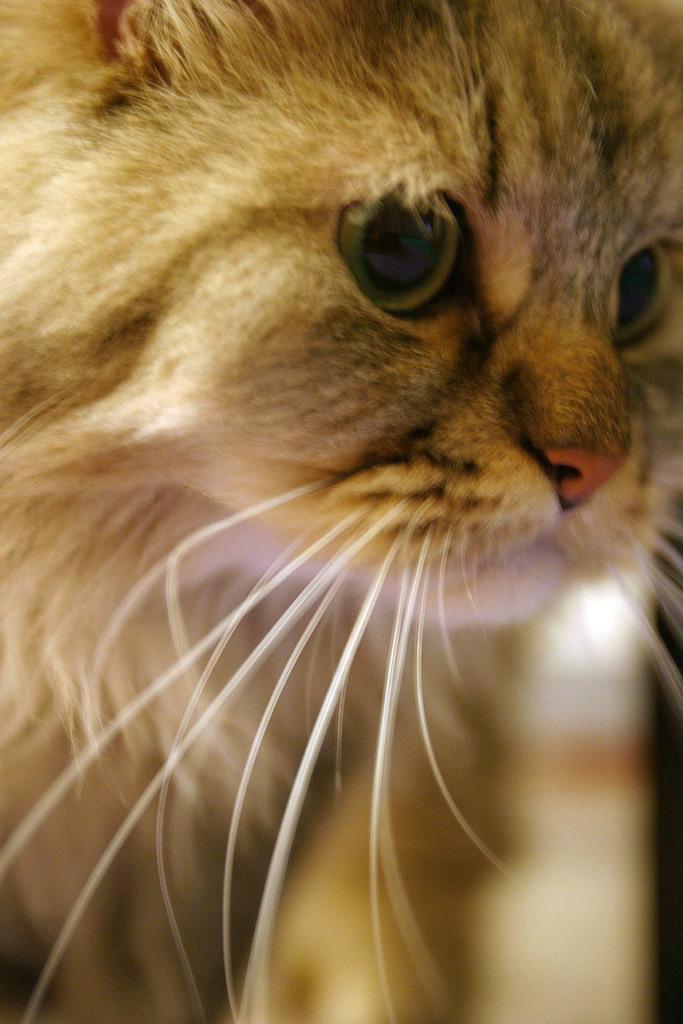How would you summarize this image in a sentence or two? In this picture we can see a cat here, we can also see whiskers of the cat. 